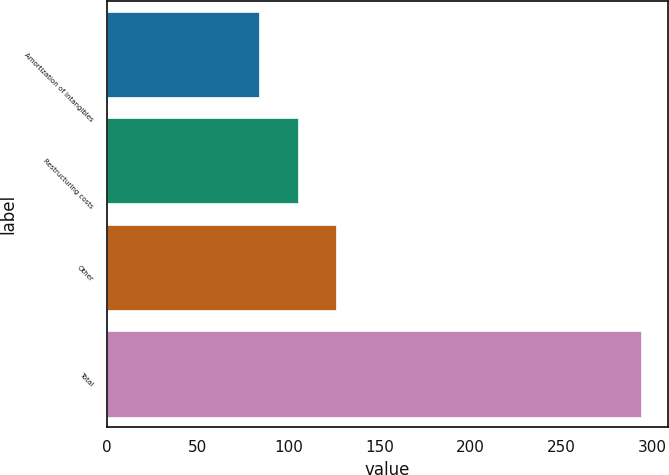Convert chart to OTSL. <chart><loc_0><loc_0><loc_500><loc_500><bar_chart><fcel>Amortization of intangibles<fcel>Restructuring costs<fcel>Other<fcel>Total<nl><fcel>84<fcel>105<fcel>126<fcel>294<nl></chart> 